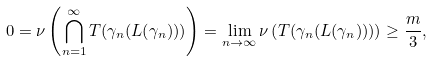Convert formula to latex. <formula><loc_0><loc_0><loc_500><loc_500>0 = \nu \left ( \bigcap _ { n = 1 } ^ { \infty } T ( \gamma _ { n } ( L ( \gamma _ { n } ) ) ) \right ) = \lim _ { n \to \infty } \nu \left ( T ( \gamma _ { n } ( L ( \gamma _ { n } ) ) ) \right ) \geq \frac { m } { 3 } ,</formula> 